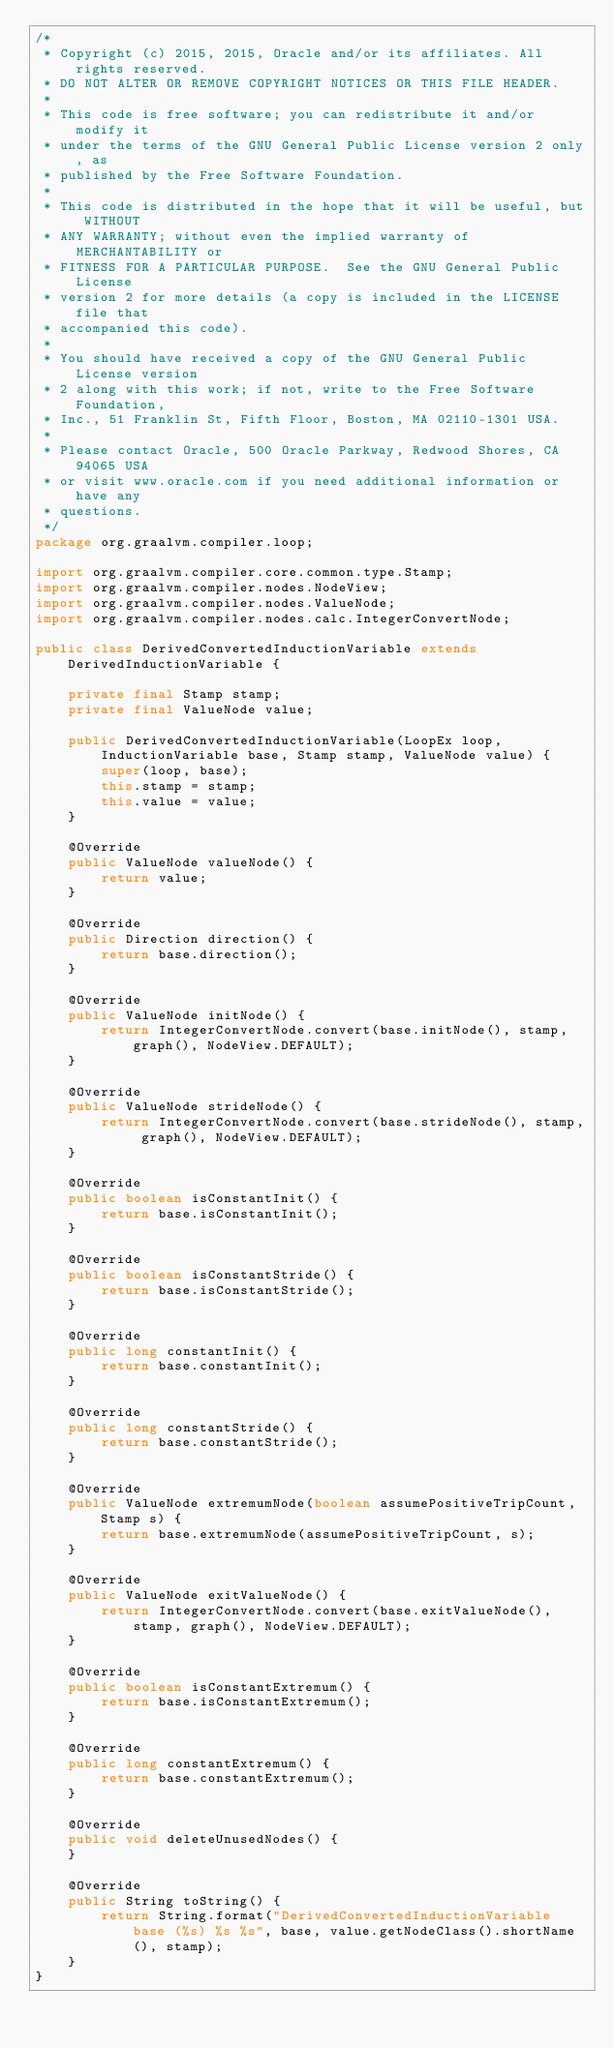<code> <loc_0><loc_0><loc_500><loc_500><_Java_>/*
 * Copyright (c) 2015, 2015, Oracle and/or its affiliates. All rights reserved.
 * DO NOT ALTER OR REMOVE COPYRIGHT NOTICES OR THIS FILE HEADER.
 *
 * This code is free software; you can redistribute it and/or modify it
 * under the terms of the GNU General Public License version 2 only, as
 * published by the Free Software Foundation.
 *
 * This code is distributed in the hope that it will be useful, but WITHOUT
 * ANY WARRANTY; without even the implied warranty of MERCHANTABILITY or
 * FITNESS FOR A PARTICULAR PURPOSE.  See the GNU General Public License
 * version 2 for more details (a copy is included in the LICENSE file that
 * accompanied this code).
 *
 * You should have received a copy of the GNU General Public License version
 * 2 along with this work; if not, write to the Free Software Foundation,
 * Inc., 51 Franklin St, Fifth Floor, Boston, MA 02110-1301 USA.
 *
 * Please contact Oracle, 500 Oracle Parkway, Redwood Shores, CA 94065 USA
 * or visit www.oracle.com if you need additional information or have any
 * questions.
 */
package org.graalvm.compiler.loop;

import org.graalvm.compiler.core.common.type.Stamp;
import org.graalvm.compiler.nodes.NodeView;
import org.graalvm.compiler.nodes.ValueNode;
import org.graalvm.compiler.nodes.calc.IntegerConvertNode;

public class DerivedConvertedInductionVariable extends DerivedInductionVariable {

    private final Stamp stamp;
    private final ValueNode value;

    public DerivedConvertedInductionVariable(LoopEx loop, InductionVariable base, Stamp stamp, ValueNode value) {
        super(loop, base);
        this.stamp = stamp;
        this.value = value;
    }

    @Override
    public ValueNode valueNode() {
        return value;
    }

    @Override
    public Direction direction() {
        return base.direction();
    }

    @Override
    public ValueNode initNode() {
        return IntegerConvertNode.convert(base.initNode(), stamp, graph(), NodeView.DEFAULT);
    }

    @Override
    public ValueNode strideNode() {
        return IntegerConvertNode.convert(base.strideNode(), stamp, graph(), NodeView.DEFAULT);
    }

    @Override
    public boolean isConstantInit() {
        return base.isConstantInit();
    }

    @Override
    public boolean isConstantStride() {
        return base.isConstantStride();
    }

    @Override
    public long constantInit() {
        return base.constantInit();
    }

    @Override
    public long constantStride() {
        return base.constantStride();
    }

    @Override
    public ValueNode extremumNode(boolean assumePositiveTripCount, Stamp s) {
        return base.extremumNode(assumePositiveTripCount, s);
    }

    @Override
    public ValueNode exitValueNode() {
        return IntegerConvertNode.convert(base.exitValueNode(), stamp, graph(), NodeView.DEFAULT);
    }

    @Override
    public boolean isConstantExtremum() {
        return base.isConstantExtremum();
    }

    @Override
    public long constantExtremum() {
        return base.constantExtremum();
    }

    @Override
    public void deleteUnusedNodes() {
    }

    @Override
    public String toString() {
        return String.format("DerivedConvertedInductionVariable base (%s) %s %s", base, value.getNodeClass().shortName(), stamp);
    }
}
</code> 